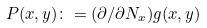Convert formula to latex. <formula><loc_0><loc_0><loc_500><loc_500>P ( x , y ) \colon = ( \partial / \partial N _ { x } ) g ( x , y )</formula> 